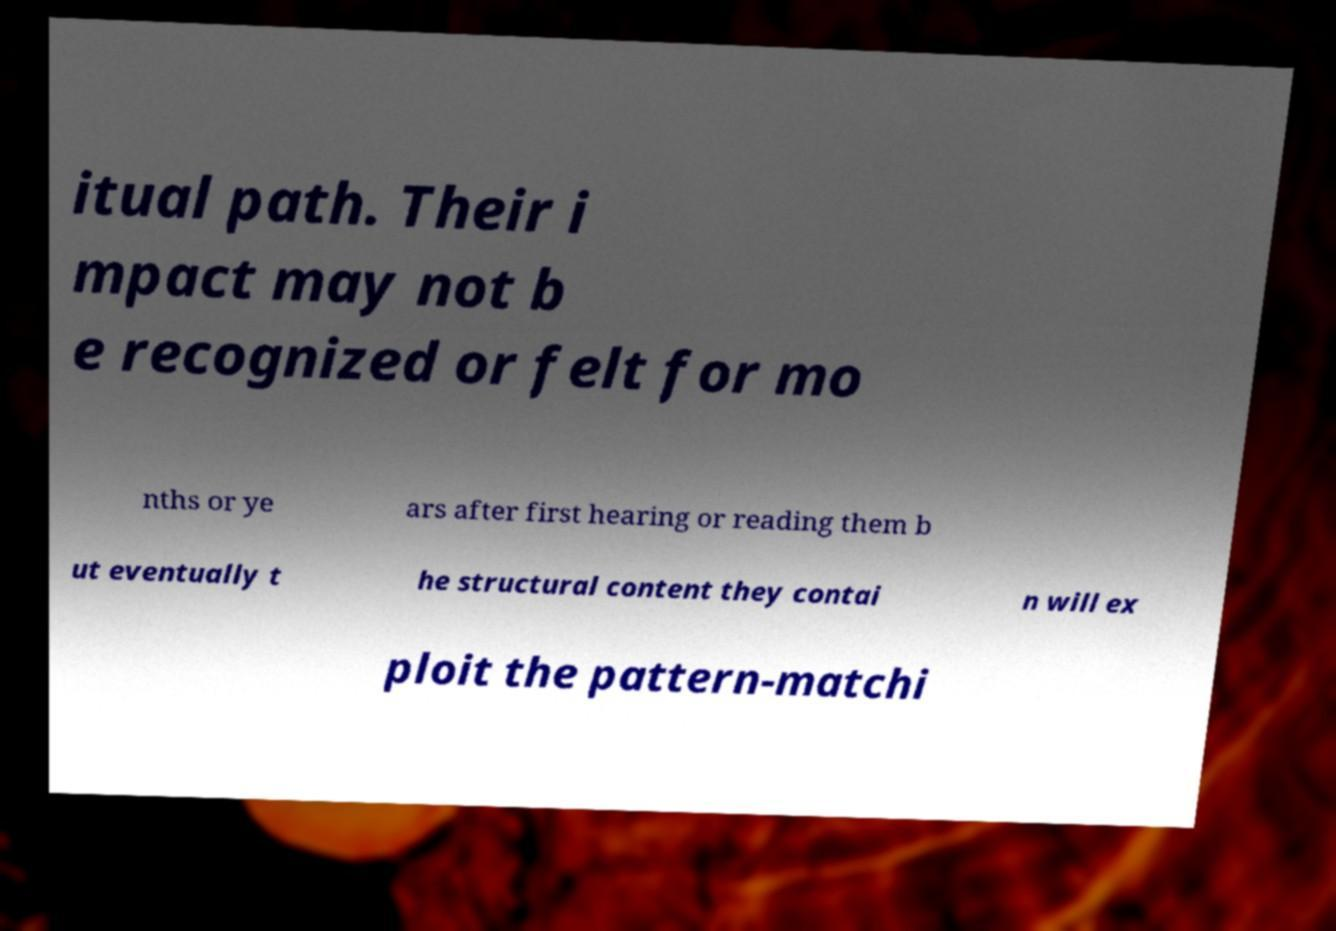Please identify and transcribe the text found in this image. itual path. Their i mpact may not b e recognized or felt for mo nths or ye ars after first hearing or reading them b ut eventually t he structural content they contai n will ex ploit the pattern-matchi 